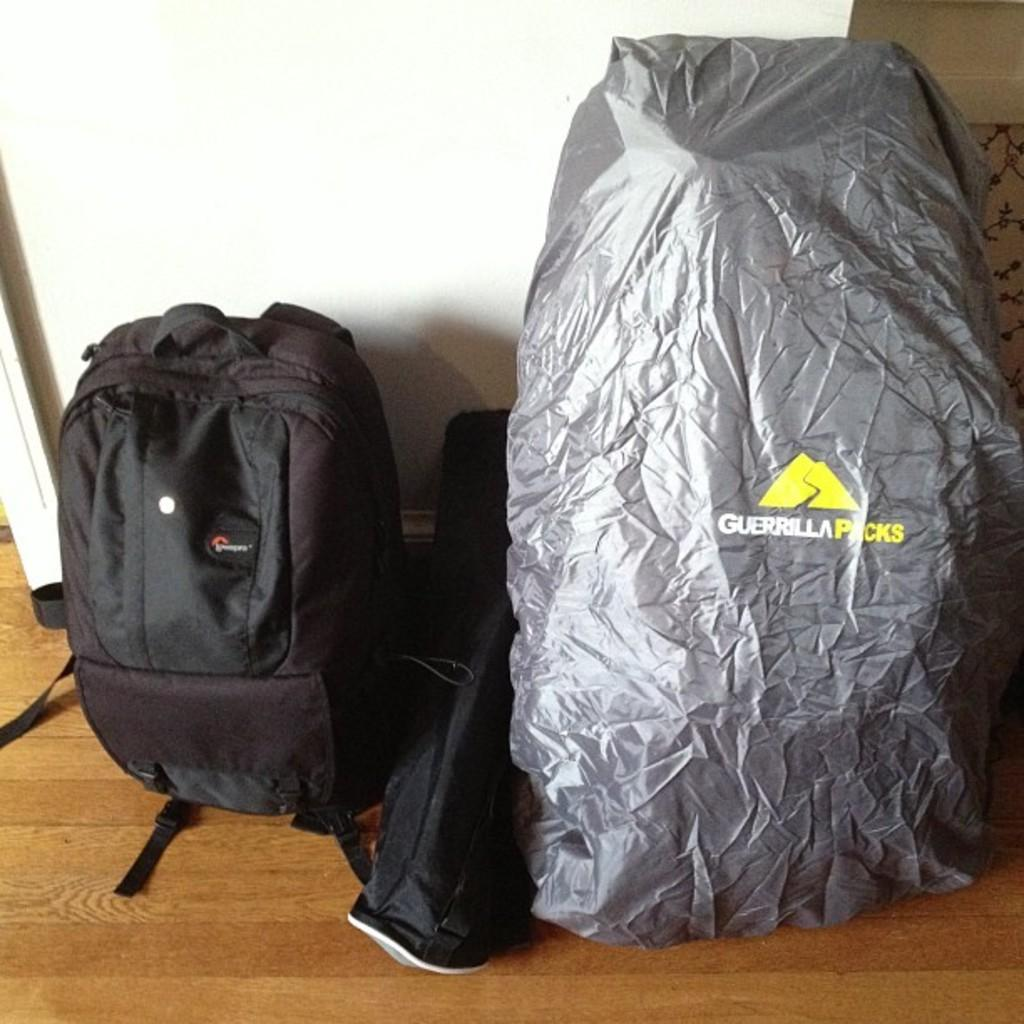Provide a one-sentence caption for the provided image. A grey item with Guerrilla Packs printed n it drapes an object. 